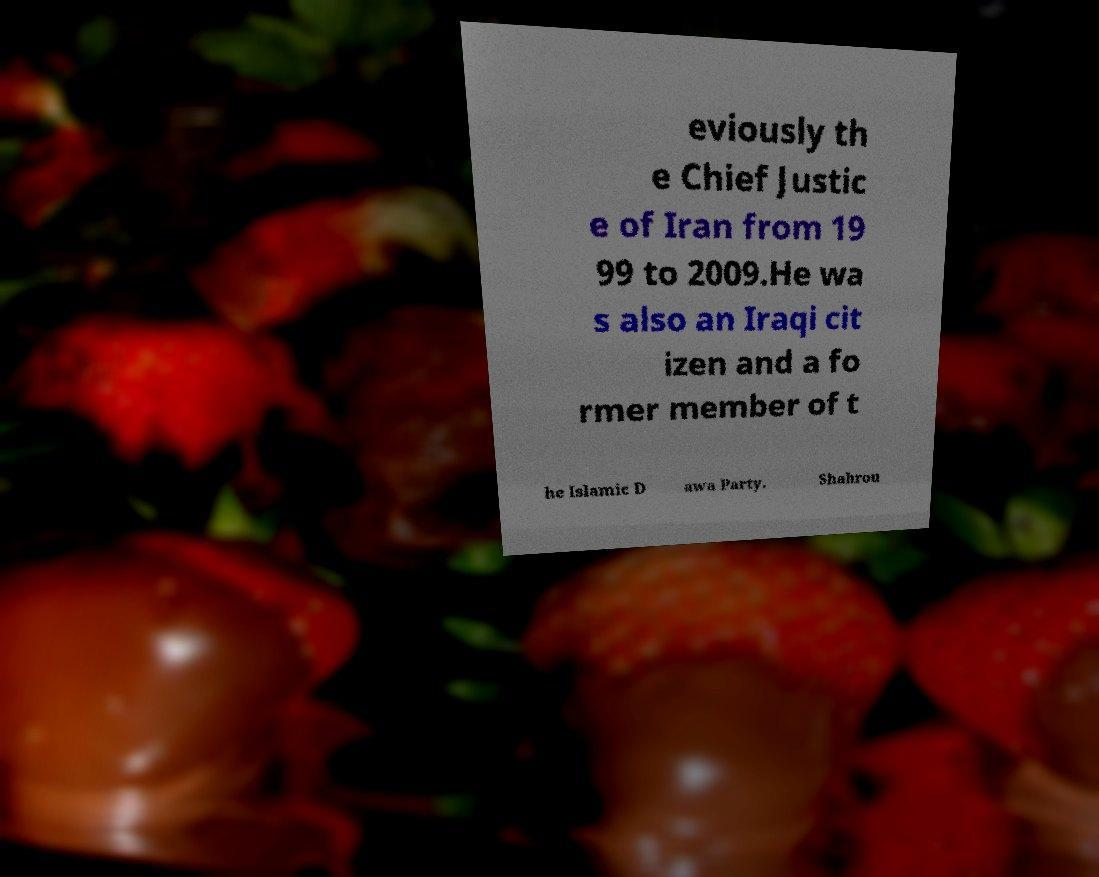There's text embedded in this image that I need extracted. Can you transcribe it verbatim? eviously th e Chief Justic e of Iran from 19 99 to 2009.He wa s also an Iraqi cit izen and a fo rmer member of t he Islamic D awa Party. Shahrou 